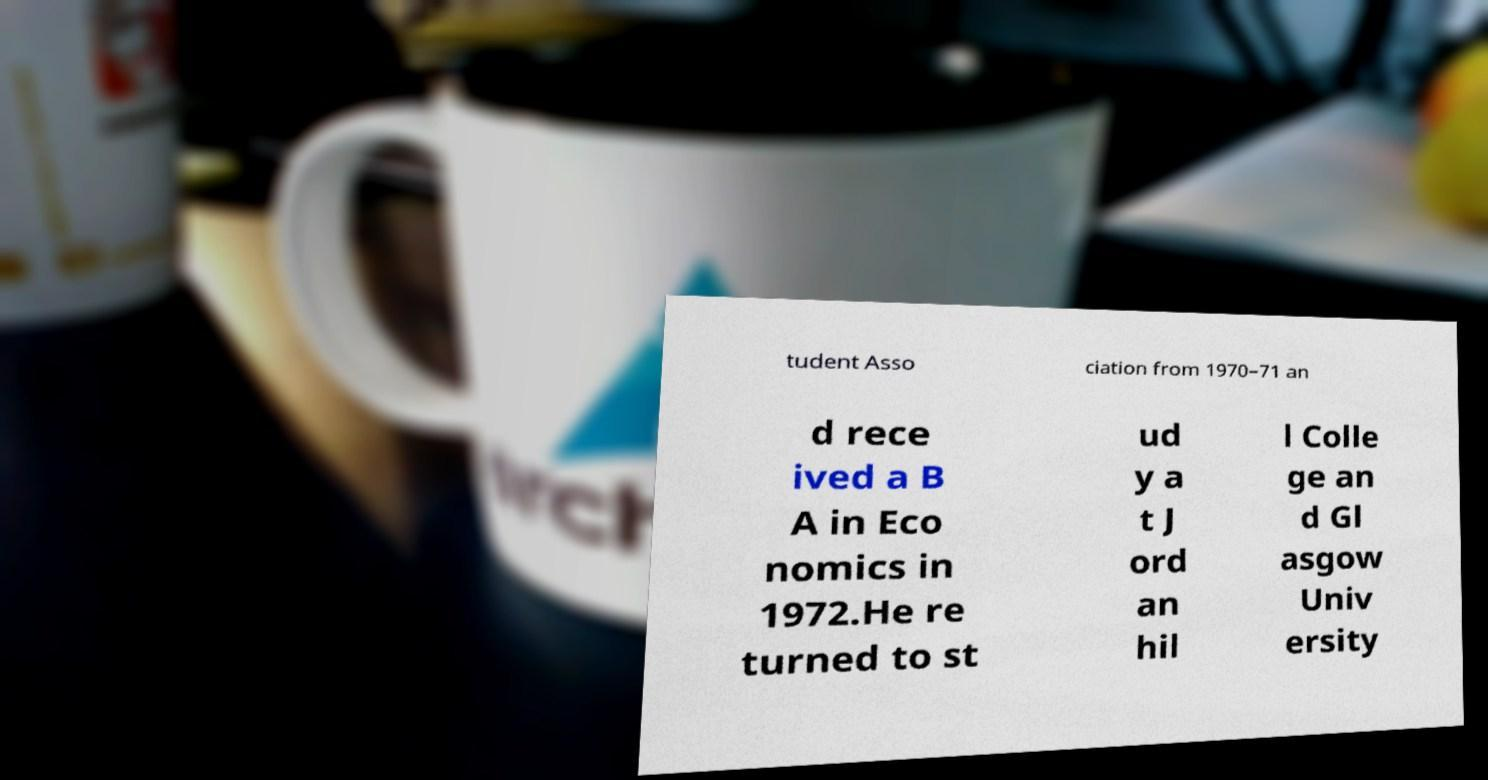Please read and relay the text visible in this image. What does it say? tudent Asso ciation from 1970–71 an d rece ived a B A in Eco nomics in 1972.He re turned to st ud y a t J ord an hil l Colle ge an d Gl asgow Univ ersity 